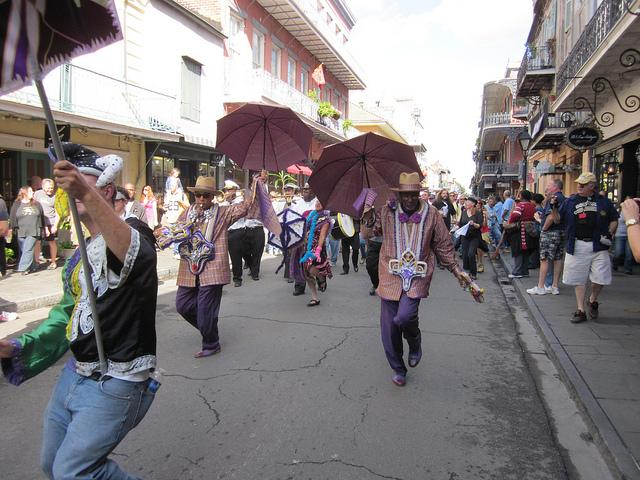What activity are people holding umbrellas taking part in?

Choices:
A) standing
B) fleeing
C) singing
D) parade parade 